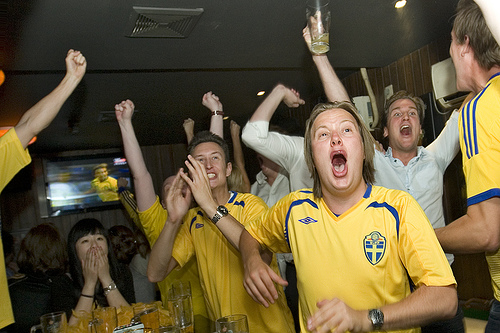<image>
Is there a boy to the left of the boy? Yes. From this viewpoint, the boy is positioned to the left side relative to the boy. 